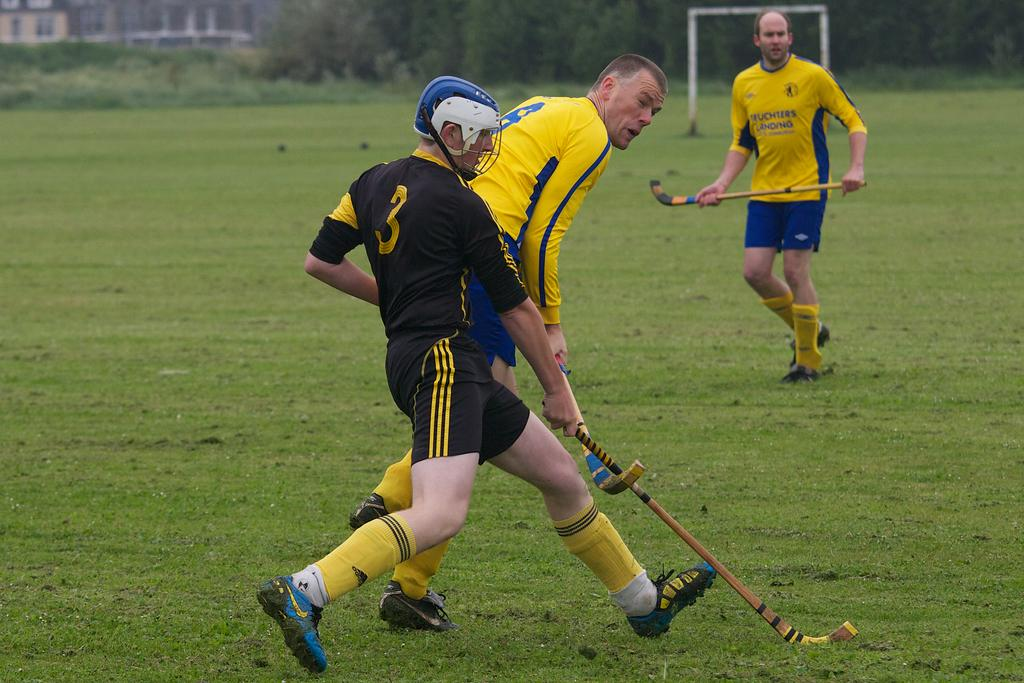<image>
Offer a succinct explanation of the picture presented. A man in a black jersey with a "3" on the back is playing a sport with men in yellow and blue jerseys. 